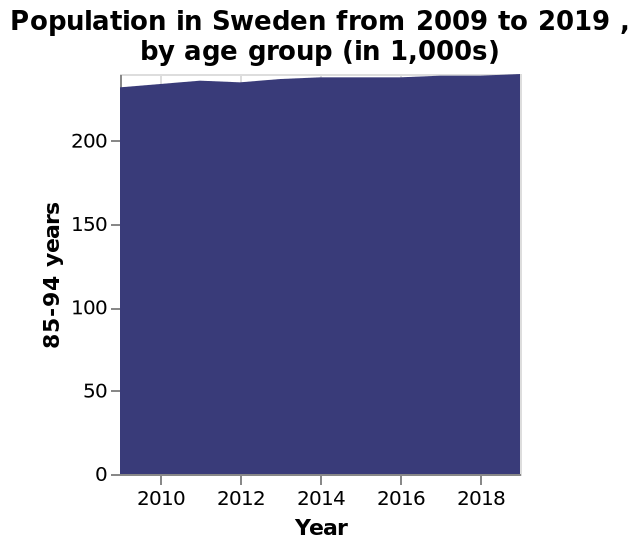<image>
What age group is represented in the area chart? The area chart represents the population in Sweden by age group, including the 85-94 years demographic. 